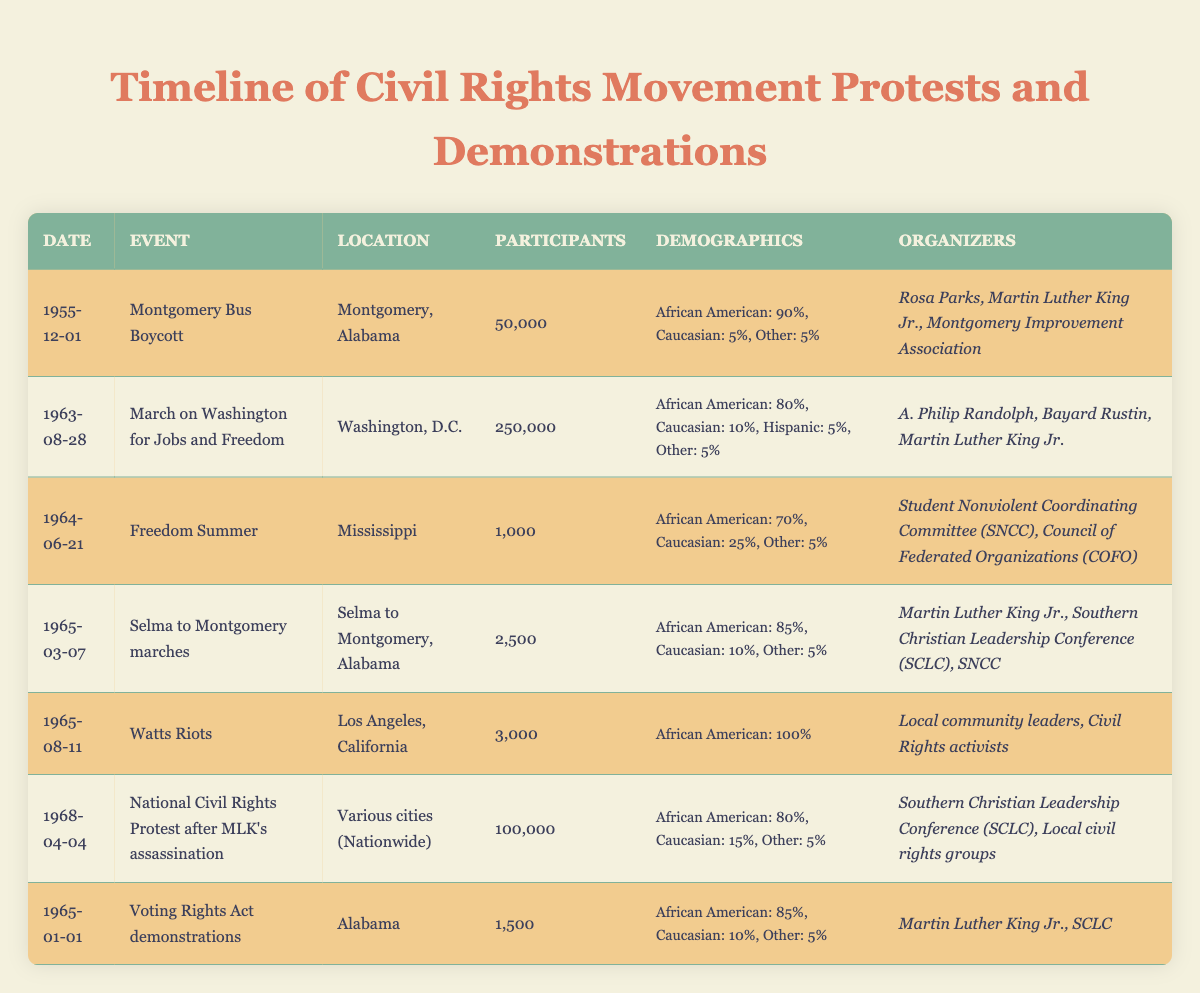What event had the highest estimated number of participants? The table shows that the "March on Washington for Jobs and Freedom" had the highest estimated participants, with 250,000.
Answer: March on Washington for Jobs and Freedom What percentage of participants in the Montgomery Bus Boycott were African American? The table indicates that 90% of the participants in the Montgomery Bus Boycott were African American.
Answer: 90% How many total demonstrations had an estimated participation of over 10,000? By checking the table, there are two events with participation over 10,000: March on Washington for Jobs and Freedom (250,000) and National Civil Rights Protest after MLK's assassination (100,000).
Answer: 2 What percentage of participants in the Watts Riots were Caucasian? The table states that 0% of participants in the Watts Riots were Caucasian.
Answer: 0% Which event had the smallest estimated number of participants, and how many were there? The table shows that "Freedom Summer" had the smallest estimated number of participants, with only 1,000 attendees.
Answer: Freedom Summer, 1000 What is the average percentage of African American participants across all events listed? The average percentage can be calculated by adding the African American percentages from each event: (90 + 80 + 70 + 85 + 100 + 80 + 85) = 570. There are 7 events, so the average is 570 / 7 = 81.43, which rounds to 81%.
Answer: 81% Did the Selma to Montgomery marches see more African American participants than Caucasian participants? The table indicates that 85% of the participants in the Selma to Montgomery marches were African American, while only 10% were Caucasian, confirming this fact.
Answer: Yes How many more participants estimated in the March on Washington than in the Watts Riots? The table shows 250,000 for the March on Washington and 3,000 for the Watts Riots. The difference is calculated as 250,000 - 3,000 = 247,000.
Answer: 247000 Which two events had the same percentage of "Other" demographic participants? The table shows that both the Montgomery Bus Boycott and the Selma to Montgomery marches had 5% of participants classified as "Other."
Answer: Montgomery Bus Boycott and Selma to Montgomery marches What was the total estimated participation in the Voting Rights Act demonstrations and the Freedom Summer combined? The Voting Rights Act demonstrations had 1,500 participants, and Freedom Summer had 1,000 participants. Adding these gives 1,500 + 1,000 = 2,500 total participants.
Answer: 2500 